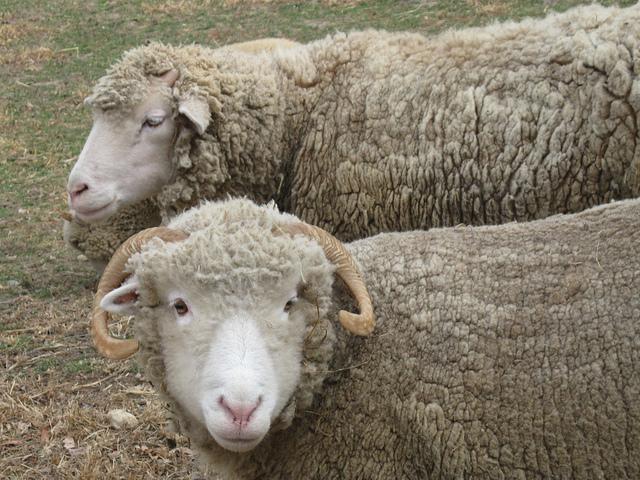Do both the sheep have horns?
Give a very brief answer. No. What color are the sheep?
Keep it brief. Gray. How many animals are pictured?
Answer briefly. 2. The sheep have horns?
Write a very short answer. Yes. 